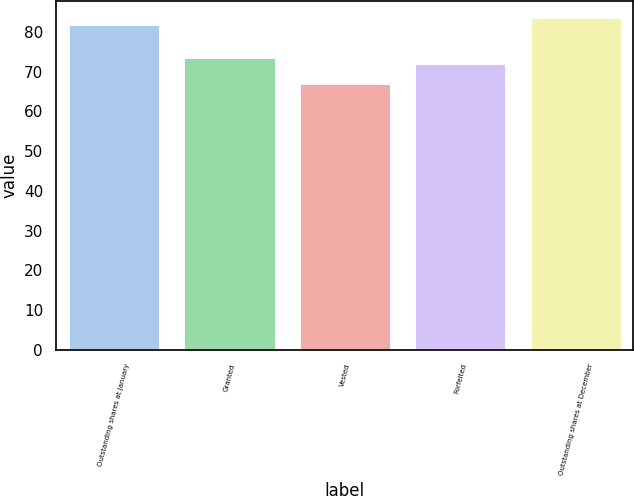<chart> <loc_0><loc_0><loc_500><loc_500><bar_chart><fcel>Outstanding shares at January<fcel>Granted<fcel>Vested<fcel>Forfeited<fcel>Outstanding shares at December<nl><fcel>82.02<fcel>73.76<fcel>67.16<fcel>72.12<fcel>83.66<nl></chart> 